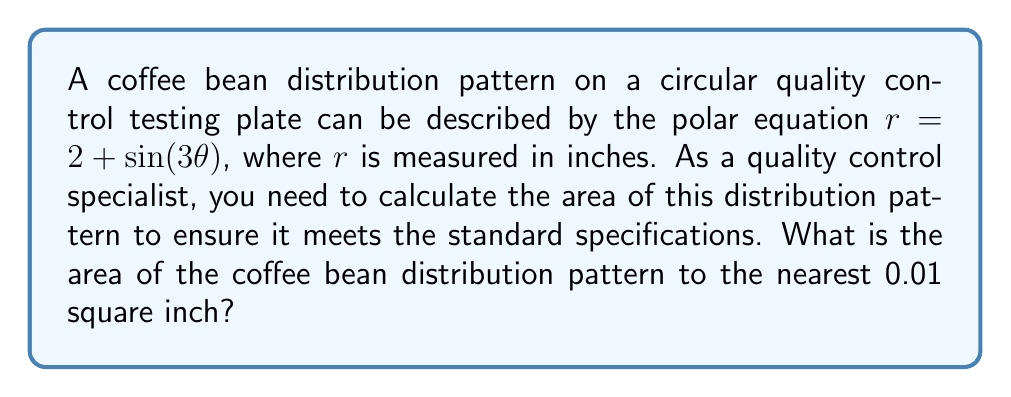Can you answer this question? To solve this problem, we need to use the formula for the area of a region in polar coordinates:

$$A = \frac{1}{2} \int_{0}^{2\pi} r^2 d\theta$$

Where $r$ is given by the equation $r = 2 + \sin(3\theta)$.

Step 1: Substitute the given equation into the area formula:
$$A = \frac{1}{2} \int_{0}^{2\pi} (2 + \sin(3\theta))^2 d\theta$$

Step 2: Expand the integrand:
$$(2 + \sin(3\theta))^2 = 4 + 4\sin(3\theta) + \sin^2(3\theta)$$

Step 3: Substitute this back into the integral:
$$A = \frac{1}{2} \int_{0}^{2\pi} (4 + 4\sin(3\theta) + \sin^2(3\theta)) d\theta$$

Step 4: Integrate each term:
- $\int_{0}^{2\pi} 4 d\theta = 4\theta |_{0}^{2\pi} = 8\pi$
- $\int_{0}^{2\pi} 4\sin(3\theta) d\theta = -\frac{4}{3}\cos(3\theta) |_{0}^{2\pi} = 0$
- $\int_{0}^{2\pi} \sin^2(3\theta) d\theta = \int_{0}^{2\pi} \frac{1-\cos(6\theta)}{2} d\theta = \frac{\theta}{2} - \frac{\sin(6\theta)}{12} |_{0}^{2\pi} = \pi$

Step 5: Sum up the results:
$$A = \frac{1}{2} (8\pi + 0 + \pi) = \frac{9\pi}{2} \approx 14.14$$

Therefore, the area of the coffee bean distribution pattern is approximately 14.14 square inches.
Answer: 14.14 square inches 